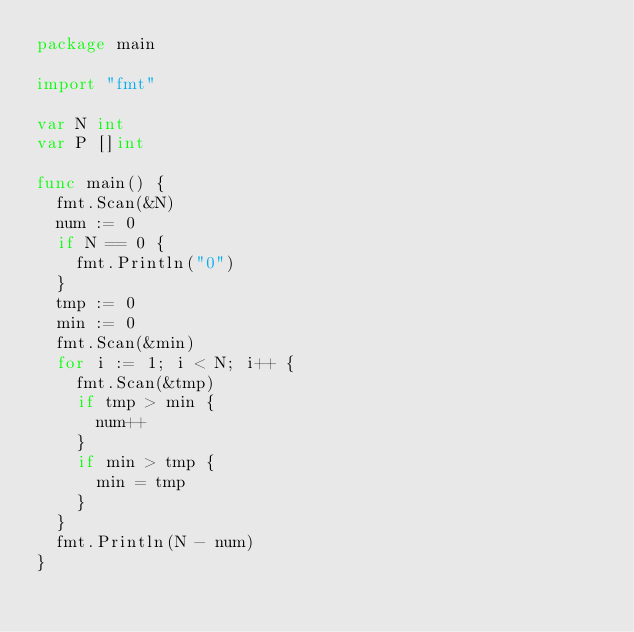Convert code to text. <code><loc_0><loc_0><loc_500><loc_500><_Go_>package main

import "fmt"

var N int
var P []int

func main() {
	fmt.Scan(&N)
	num := 0
	if N == 0 {
		fmt.Println("0")
	}
	tmp := 0
	min := 0
	fmt.Scan(&min)
	for i := 1; i < N; i++ {
		fmt.Scan(&tmp)
		if tmp > min {
			num++
		}
		if min > tmp {
			min = tmp
		}
	}
	fmt.Println(N - num)
}
</code> 